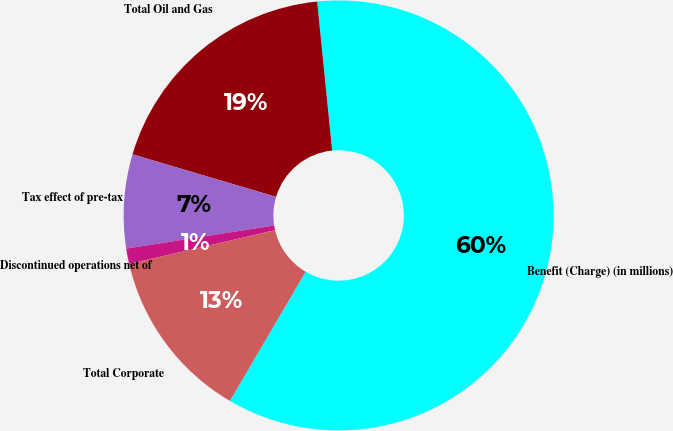Convert chart. <chart><loc_0><loc_0><loc_500><loc_500><pie_chart><fcel>Benefit (Charge) (in millions)<fcel>Total Oil and Gas<fcel>Tax effect of pre-tax<fcel>Discontinued operations net of<fcel>Total Corporate<nl><fcel>60.03%<fcel>18.82%<fcel>7.05%<fcel>1.16%<fcel>12.94%<nl></chart> 